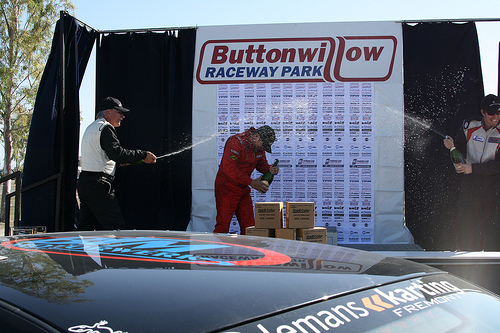<image>
Can you confirm if the box is on the car? No. The box is not positioned on the car. They may be near each other, but the box is not supported by or resting on top of the car. 